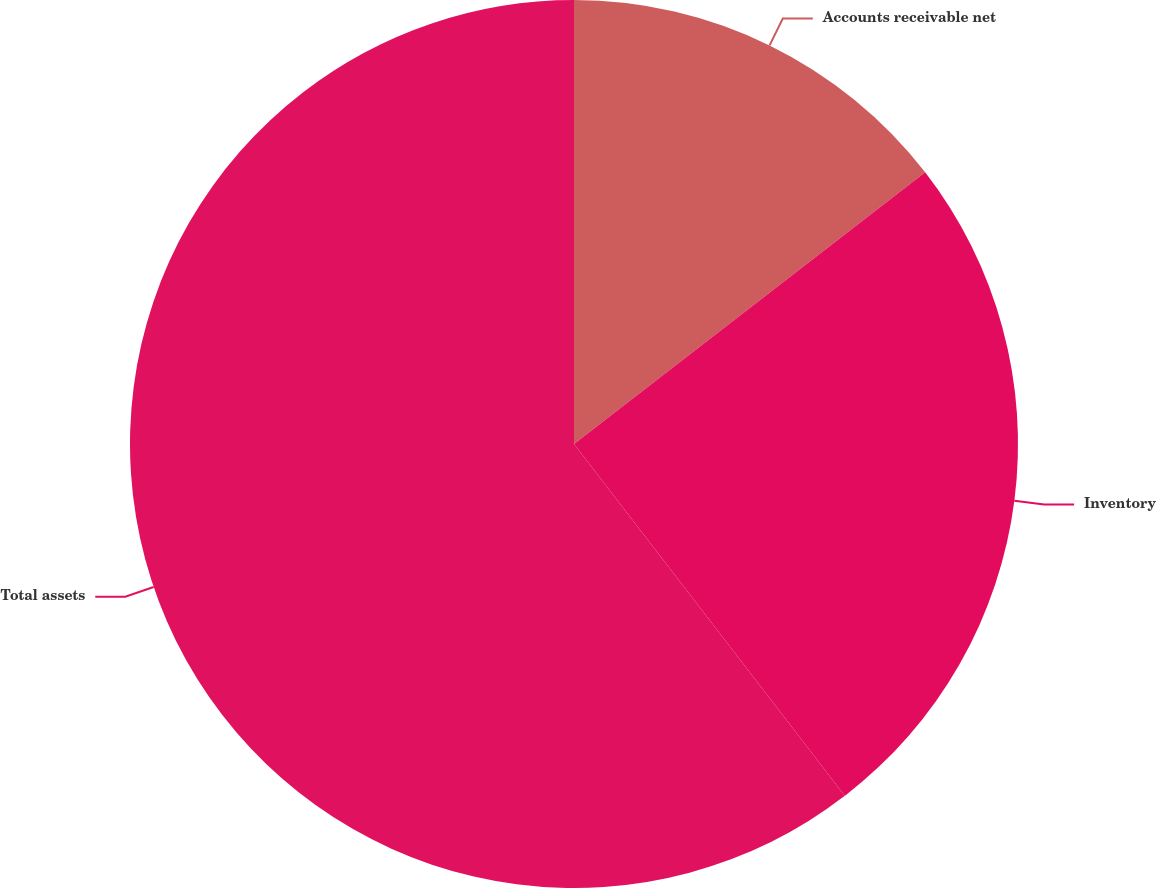<chart> <loc_0><loc_0><loc_500><loc_500><pie_chart><fcel>Accounts receivable net<fcel>Inventory<fcel>Total assets<nl><fcel>14.52%<fcel>25.04%<fcel>60.44%<nl></chart> 